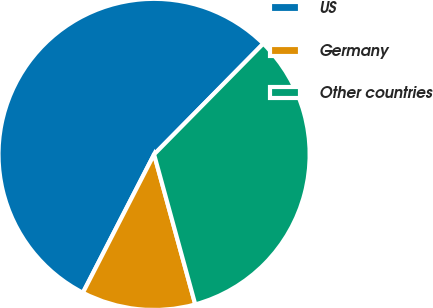Convert chart. <chart><loc_0><loc_0><loc_500><loc_500><pie_chart><fcel>US<fcel>Germany<fcel>Other countries<nl><fcel>54.82%<fcel>11.83%<fcel>33.35%<nl></chart> 